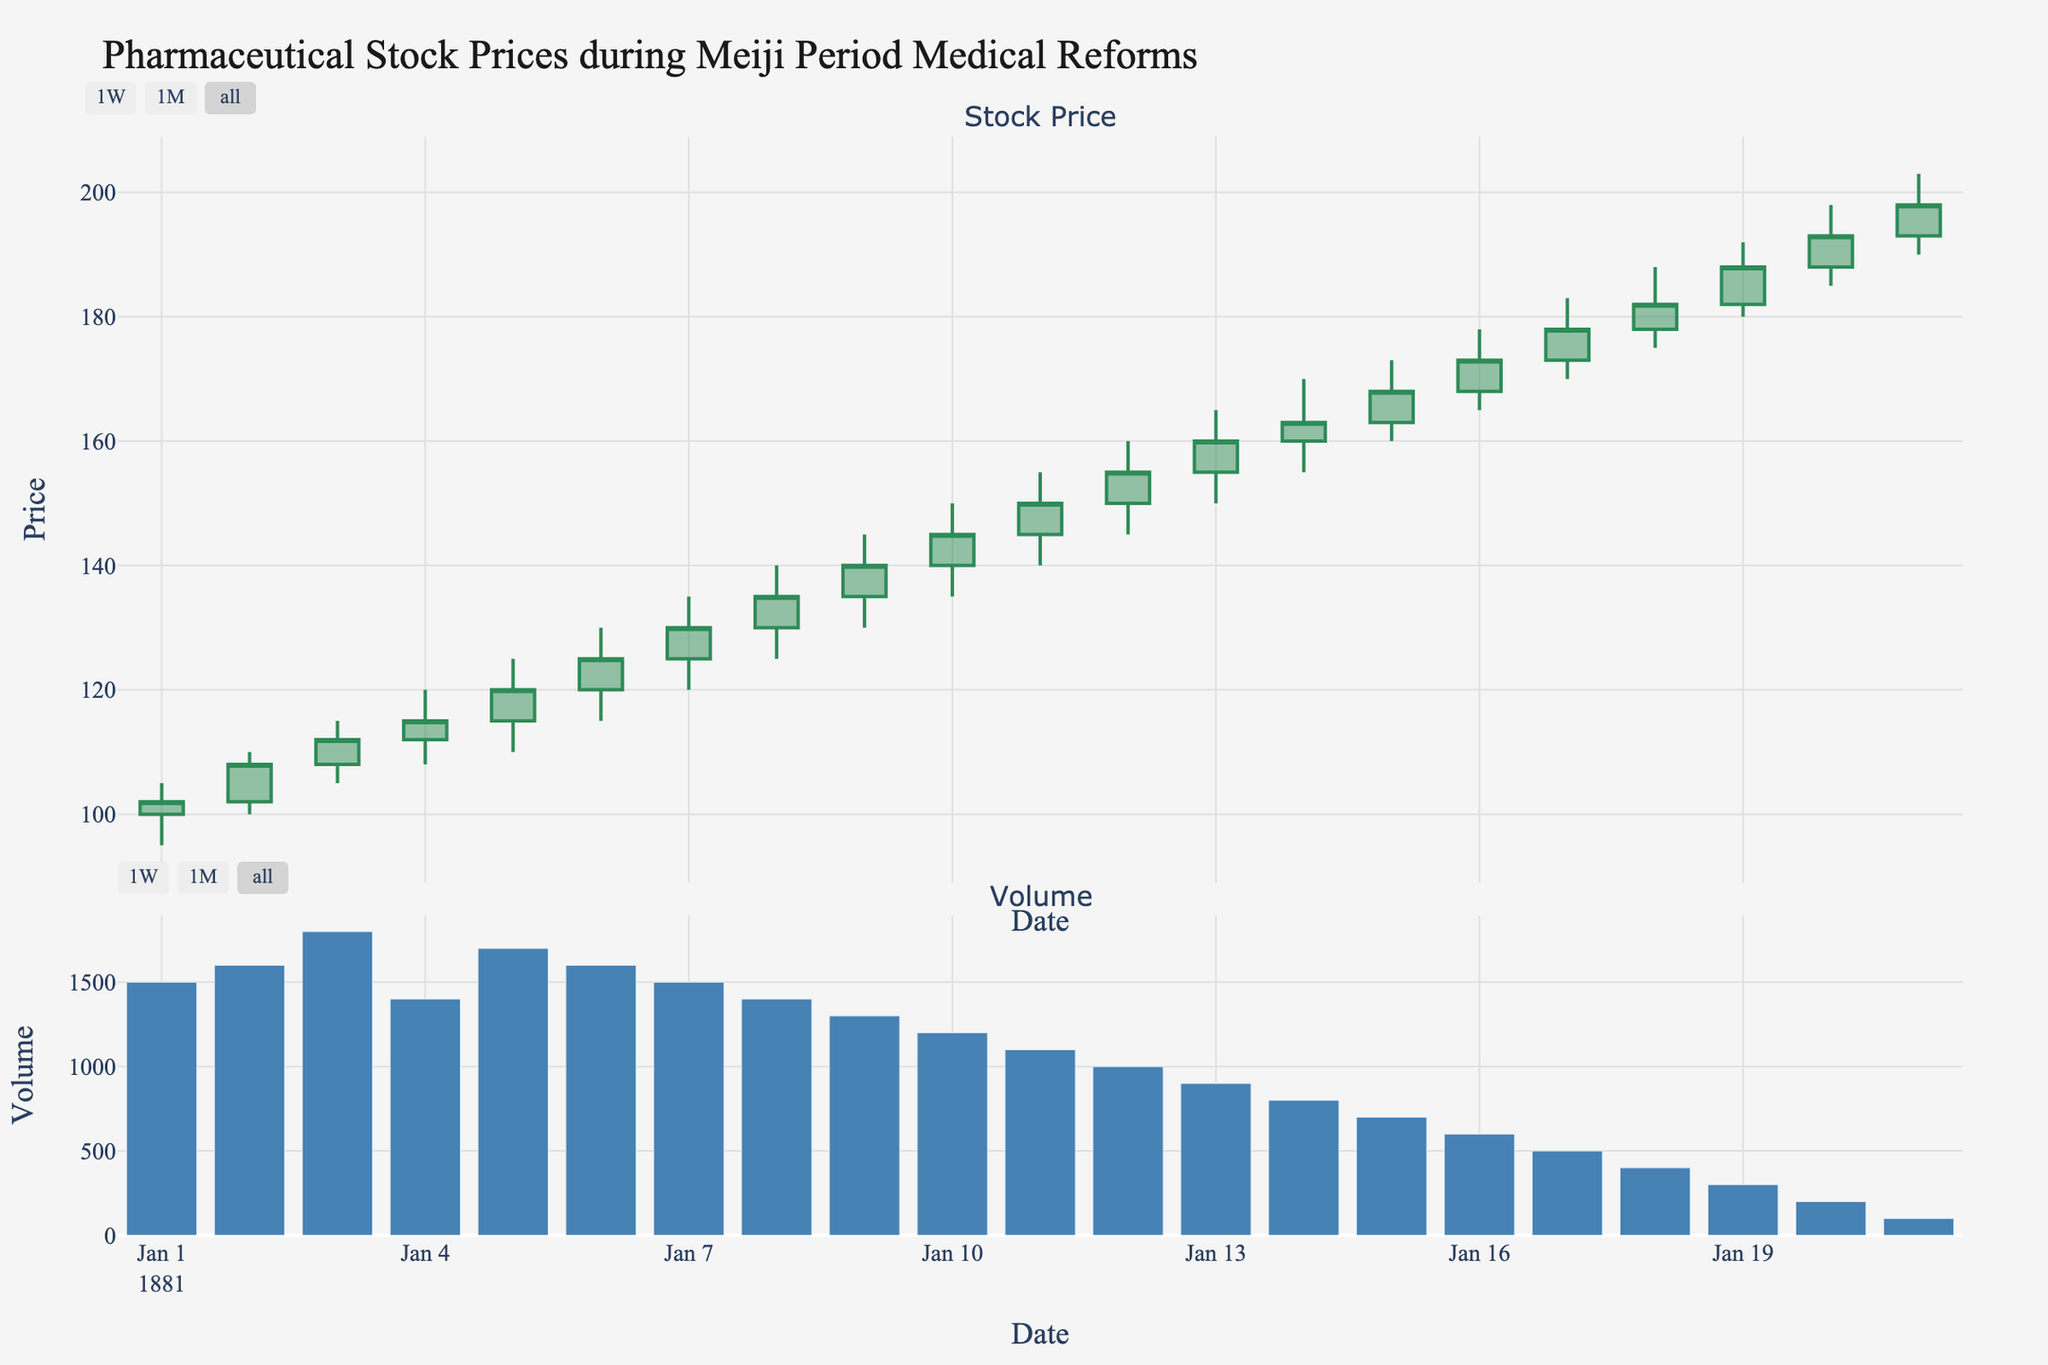What is the title of the figure? The title of the figure is displayed at the top of the chart. It summarizes the theme of the visualized data.
Answer: Pharmaceutical Stock Prices during Meiji Period Medical Reforms How many companies are displayed in the figure? There are multiple companies listed in the data provided. By counting the unique company names, we can determine the number of companies represented.
Answer: 5 Which company's stock had the highest closing price? Reviewing the candlestick plot and checking the highest closing value across all companies allows us to identify the company with the highest closing price.
Answer: Shionogi On which date did Shionogi have its highest closing price? By inspecting the section of the plot specific to Shionogi and identifying the date corresponding to the peak closing price, we find the answer.
Answer: 1881-01-21 What was the volume of trading on 1881-01-10? Locate the bar underneath the candlestick plot for the date 1881-01-10, which will provide the volume of trading on that specific date.
Answer: 1200 What is the average closing price of Astellas Pharma over the displayed dates? To find the average closing price, sum up all the closing prices for Astellas Pharma and divide by the number of those closing prices. For Astellas Pharma, these are (120 + 135 + 145 + 168 + 193). The average is (120 + 135 + 145 + 168 + 193)/5.
Answer: 152.2 Which day saw the largest single-day increase in stock price for Takeda Pharmaceutical? Identify the days when Takeda Pharmaceutical is displayed and calculate the daily price increase (Close - Open) for each. The day with the highest single-day increase is the answer.
Answer: 1881-01-12 Between which dates did Ono Pharmaceutical see the greatest decrease in stock price? Check the candlestick plot for Ono Pharmaceutical and find the consecutive dates where the closing price dropped the most.
Answer: 1881-01-14 to 1881-01-15 What is the median trading volume of Daiichi Sankyo? List the trading volumes for Daiichi Sankyo and find the middle value of these volumes. The volumes are 1800, 1400, 900, and 400. As there is an even number of data points, the median is the average of the two middle numbers. Hence, median = (1400 + 900)/2.
Answer: 1150 Which company saw the highest average stock price over the entire period? Calculate the average stock price (sum of closing prices divided by the number of days) for each company and compare the values to determine the highest one. The average prices can be calculated individually and compared.
Answer: Shionogi 